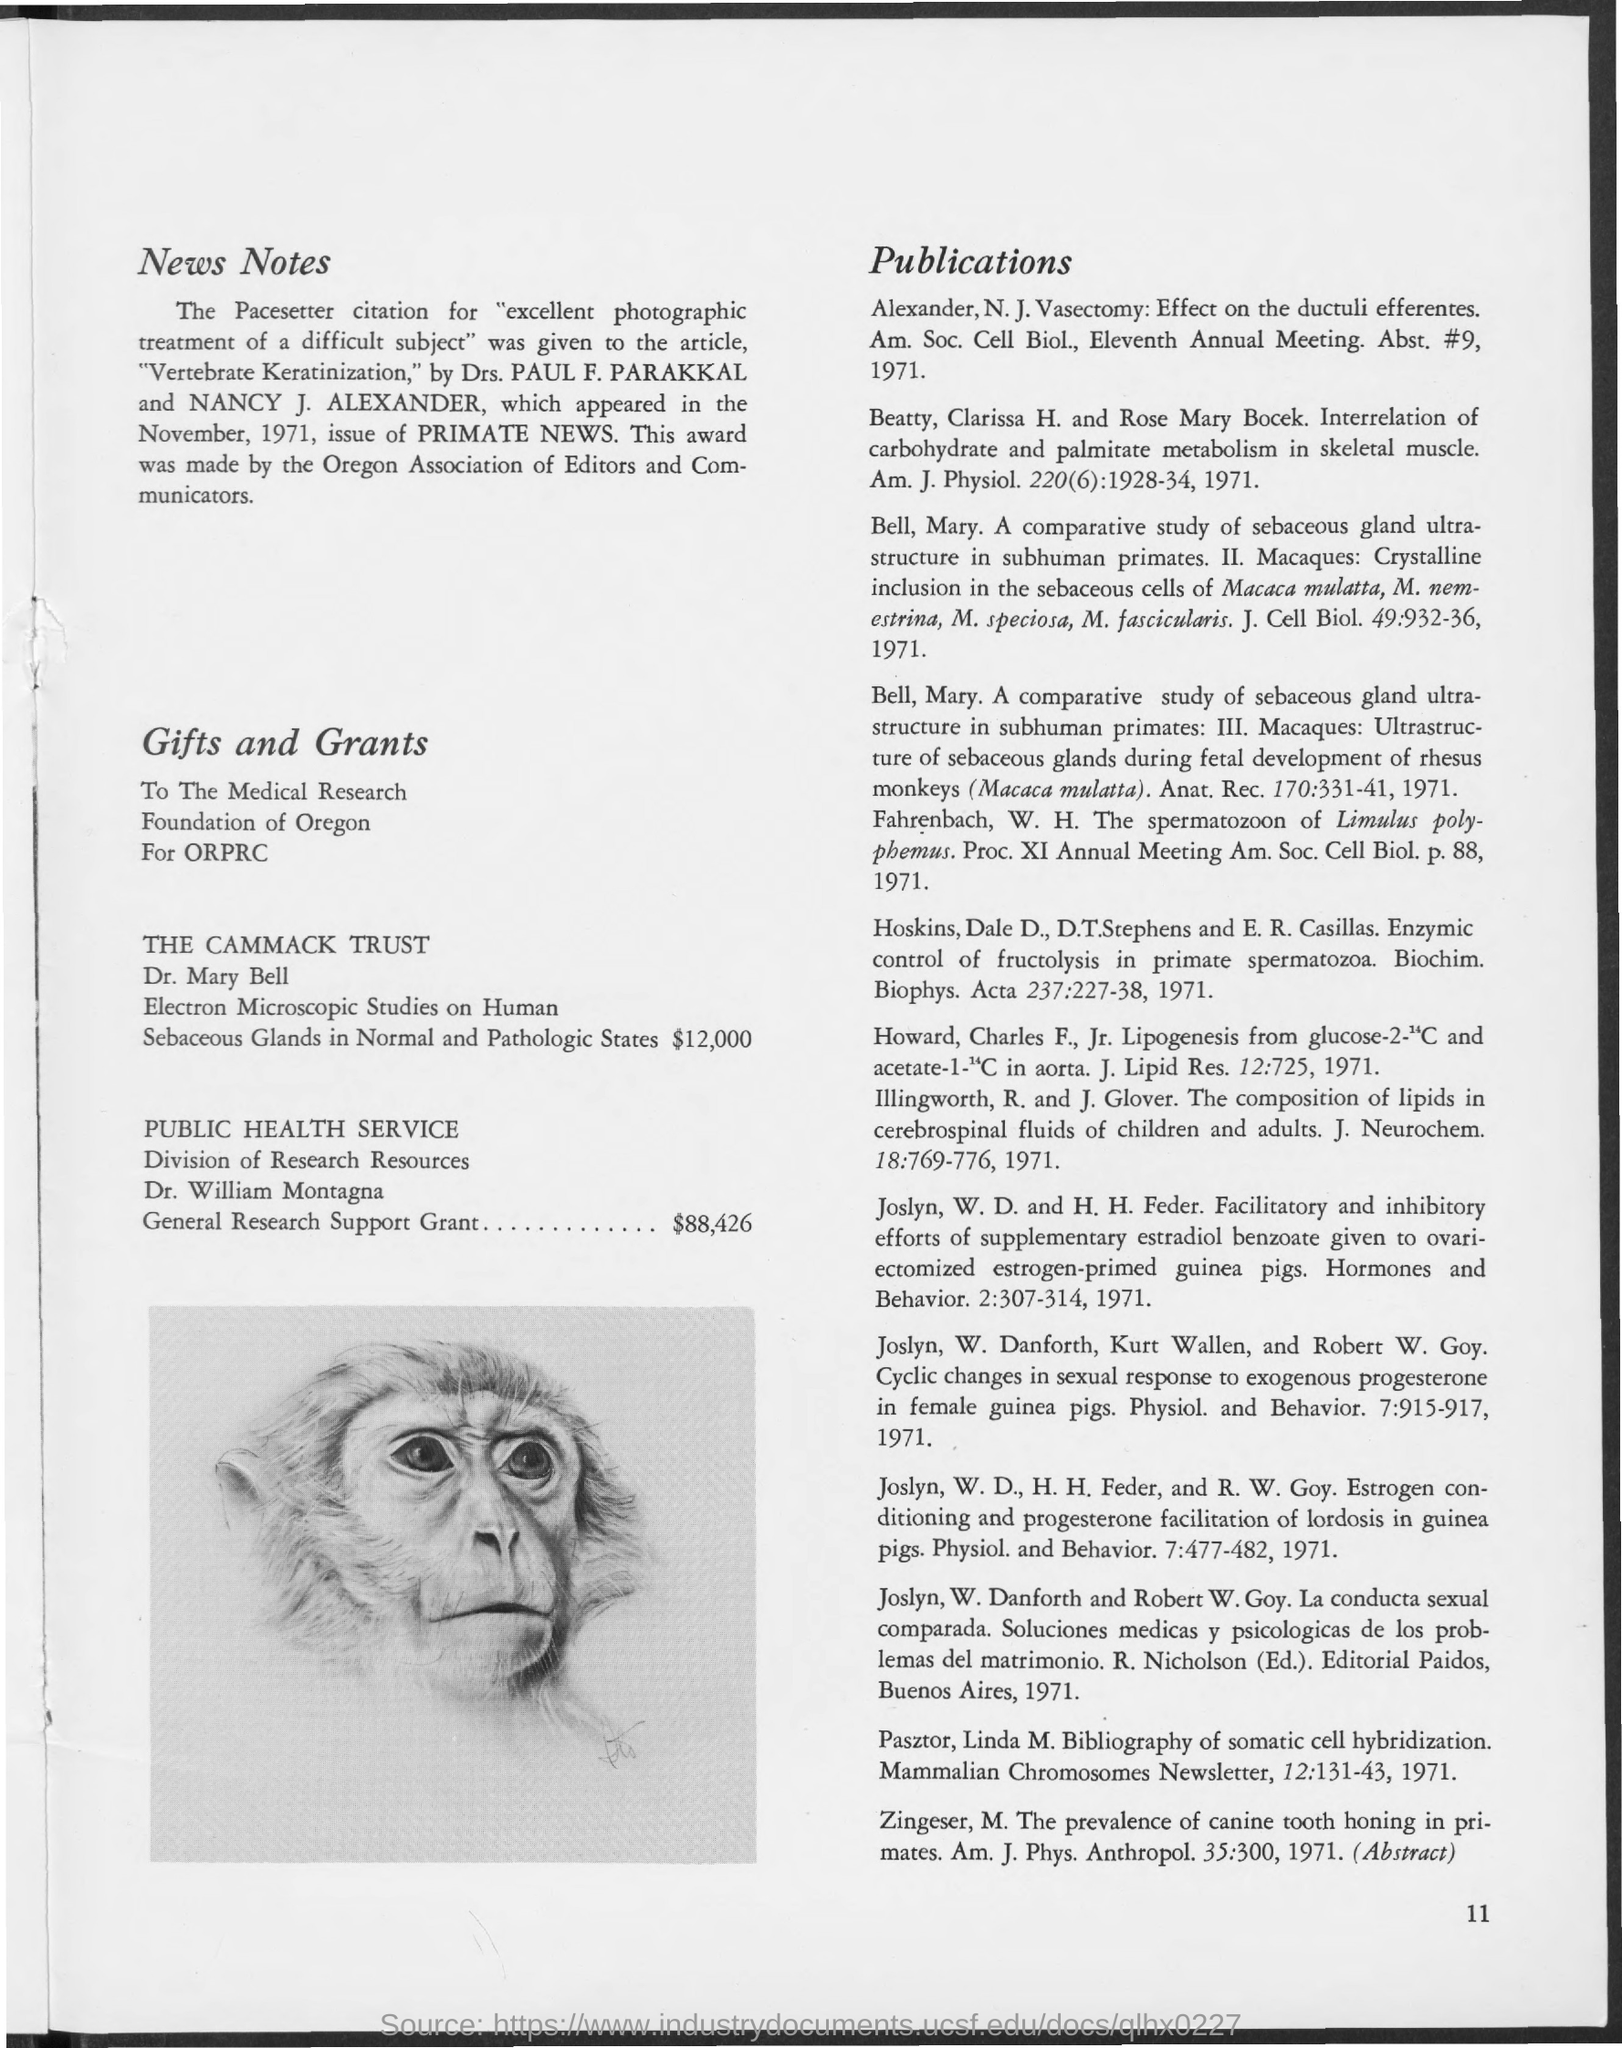Mention a couple of crucial points in this snapshot. The award was made by the Oregon Association of Editors and Communicators. The article entitled "Vertebrate Keratinization" received the Pacesetter citation for its excellent photographic treatment of a difficult subject. The authors of the article titled "Vertebrate Keratinization" are Drs. Paul F. Parakkal and Nancy J. Alexander. The article "Vertebrate Keratinization" appeared in the November 1971 issue of Primate News. The General Research Support Grant is valued at $88,426. 